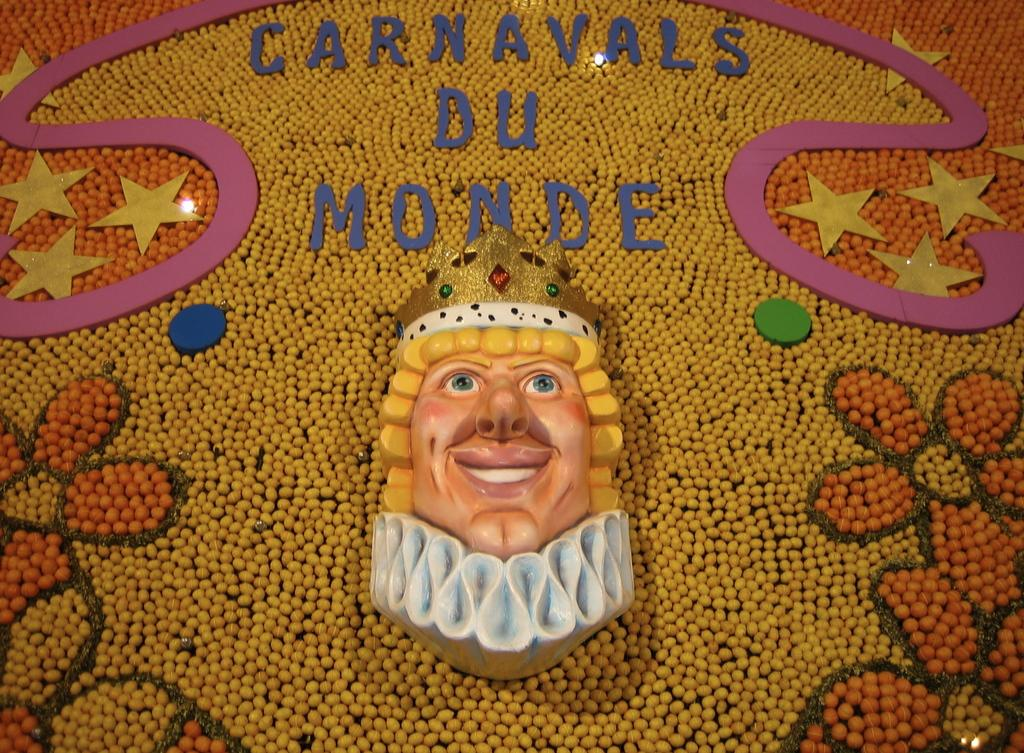What types of objects can be seen in the image? There are decorative items in the image. Is there any text present in the image? Yes, there is text in the image. How many apples are hanging from the decorative items in the image? There are no apples present in the image; it only contains decorative items and text. Can you see any signs of a vacation in the image? There is no indication of a vacation in the image, as it only features decorative items and text. 